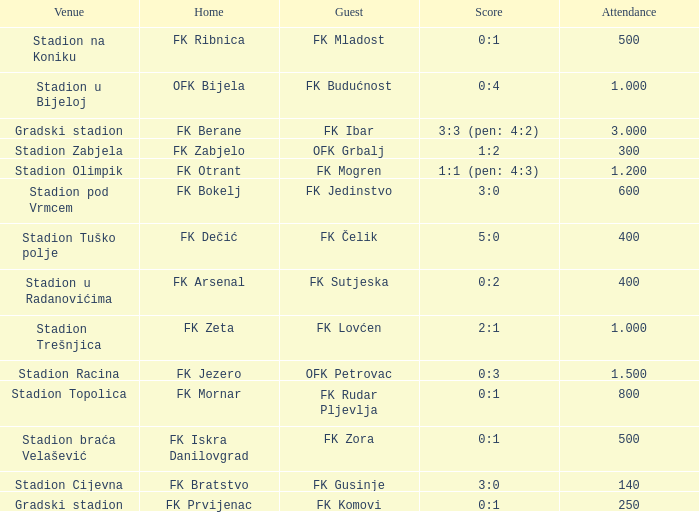What was the score for the game with FK Bratstvo as home team? 3:0. Would you be able to parse every entry in this table? {'header': ['Venue', 'Home', 'Guest', 'Score', 'Attendance'], 'rows': [['Stadion na Koniku', 'FK Ribnica', 'FK Mladost', '0:1', '500'], ['Stadion u Bijeloj', 'OFK Bijela', 'FK Budućnost', '0:4', '1.000'], ['Gradski stadion', 'FK Berane', 'FK Ibar', '3:3 (pen: 4:2)', '3.000'], ['Stadion Zabjela', 'FK Zabjelo', 'OFK Grbalj', '1:2', '300'], ['Stadion Olimpik', 'FK Otrant', 'FK Mogren', '1:1 (pen: 4:3)', '1.200'], ['Stadion pod Vrmcem', 'FK Bokelj', 'FK Jedinstvo', '3:0', '600'], ['Stadion Tuško polje', 'FK Dečić', 'FK Čelik', '5:0', '400'], ['Stadion u Radanovićima', 'FK Arsenal', 'FK Sutjeska', '0:2', '400'], ['Stadion Trešnjica', 'FK Zeta', 'FK Lovćen', '2:1', '1.000'], ['Stadion Racina', 'FK Jezero', 'OFK Petrovac', '0:3', '1.500'], ['Stadion Topolica', 'FK Mornar', 'FK Rudar Pljevlja', '0:1', '800'], ['Stadion braća Velašević', 'FK Iskra Danilovgrad', 'FK Zora', '0:1', '500'], ['Stadion Cijevna', 'FK Bratstvo', 'FK Gusinje', '3:0', '140'], ['Gradski stadion', 'FK Prvijenac', 'FK Komovi', '0:1', '250']]} 